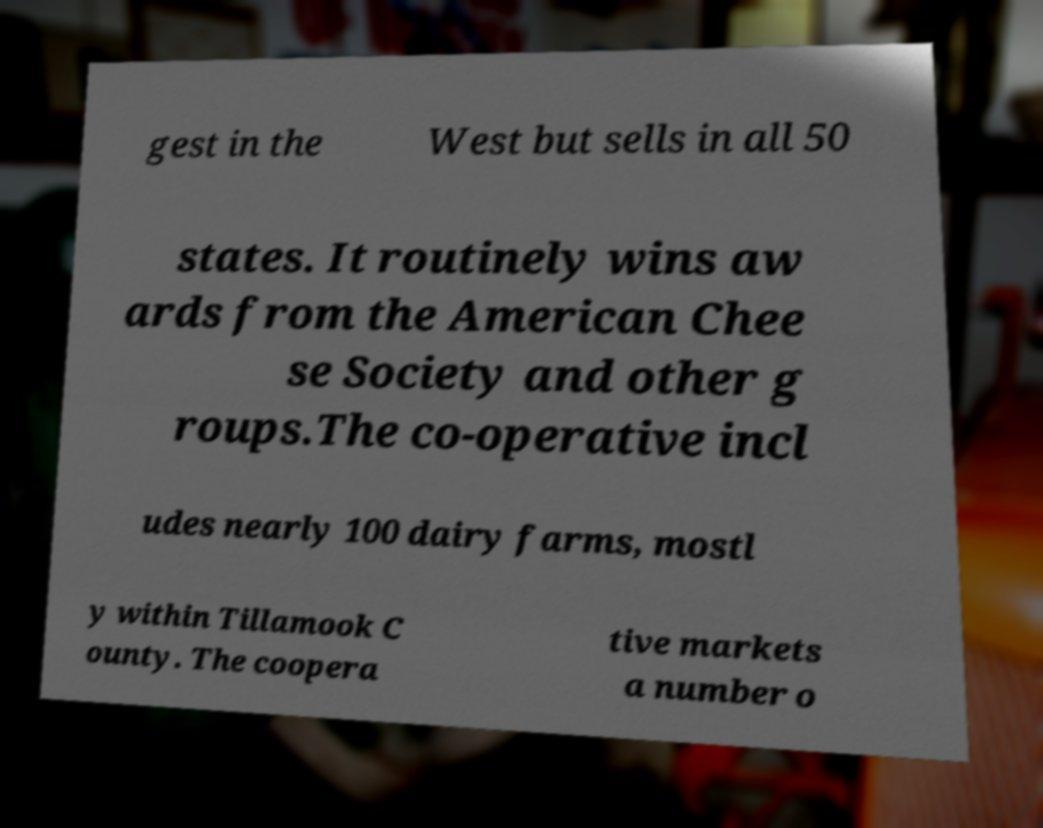I need the written content from this picture converted into text. Can you do that? gest in the West but sells in all 50 states. It routinely wins aw ards from the American Chee se Society and other g roups.The co-operative incl udes nearly 100 dairy farms, mostl y within Tillamook C ounty. The coopera tive markets a number o 